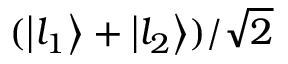Convert formula to latex. <formula><loc_0><loc_0><loc_500><loc_500>( \left | l _ { 1 } \right \rangle + \left | l _ { 2 } \right \rangle ) / \sqrt { 2 }</formula> 